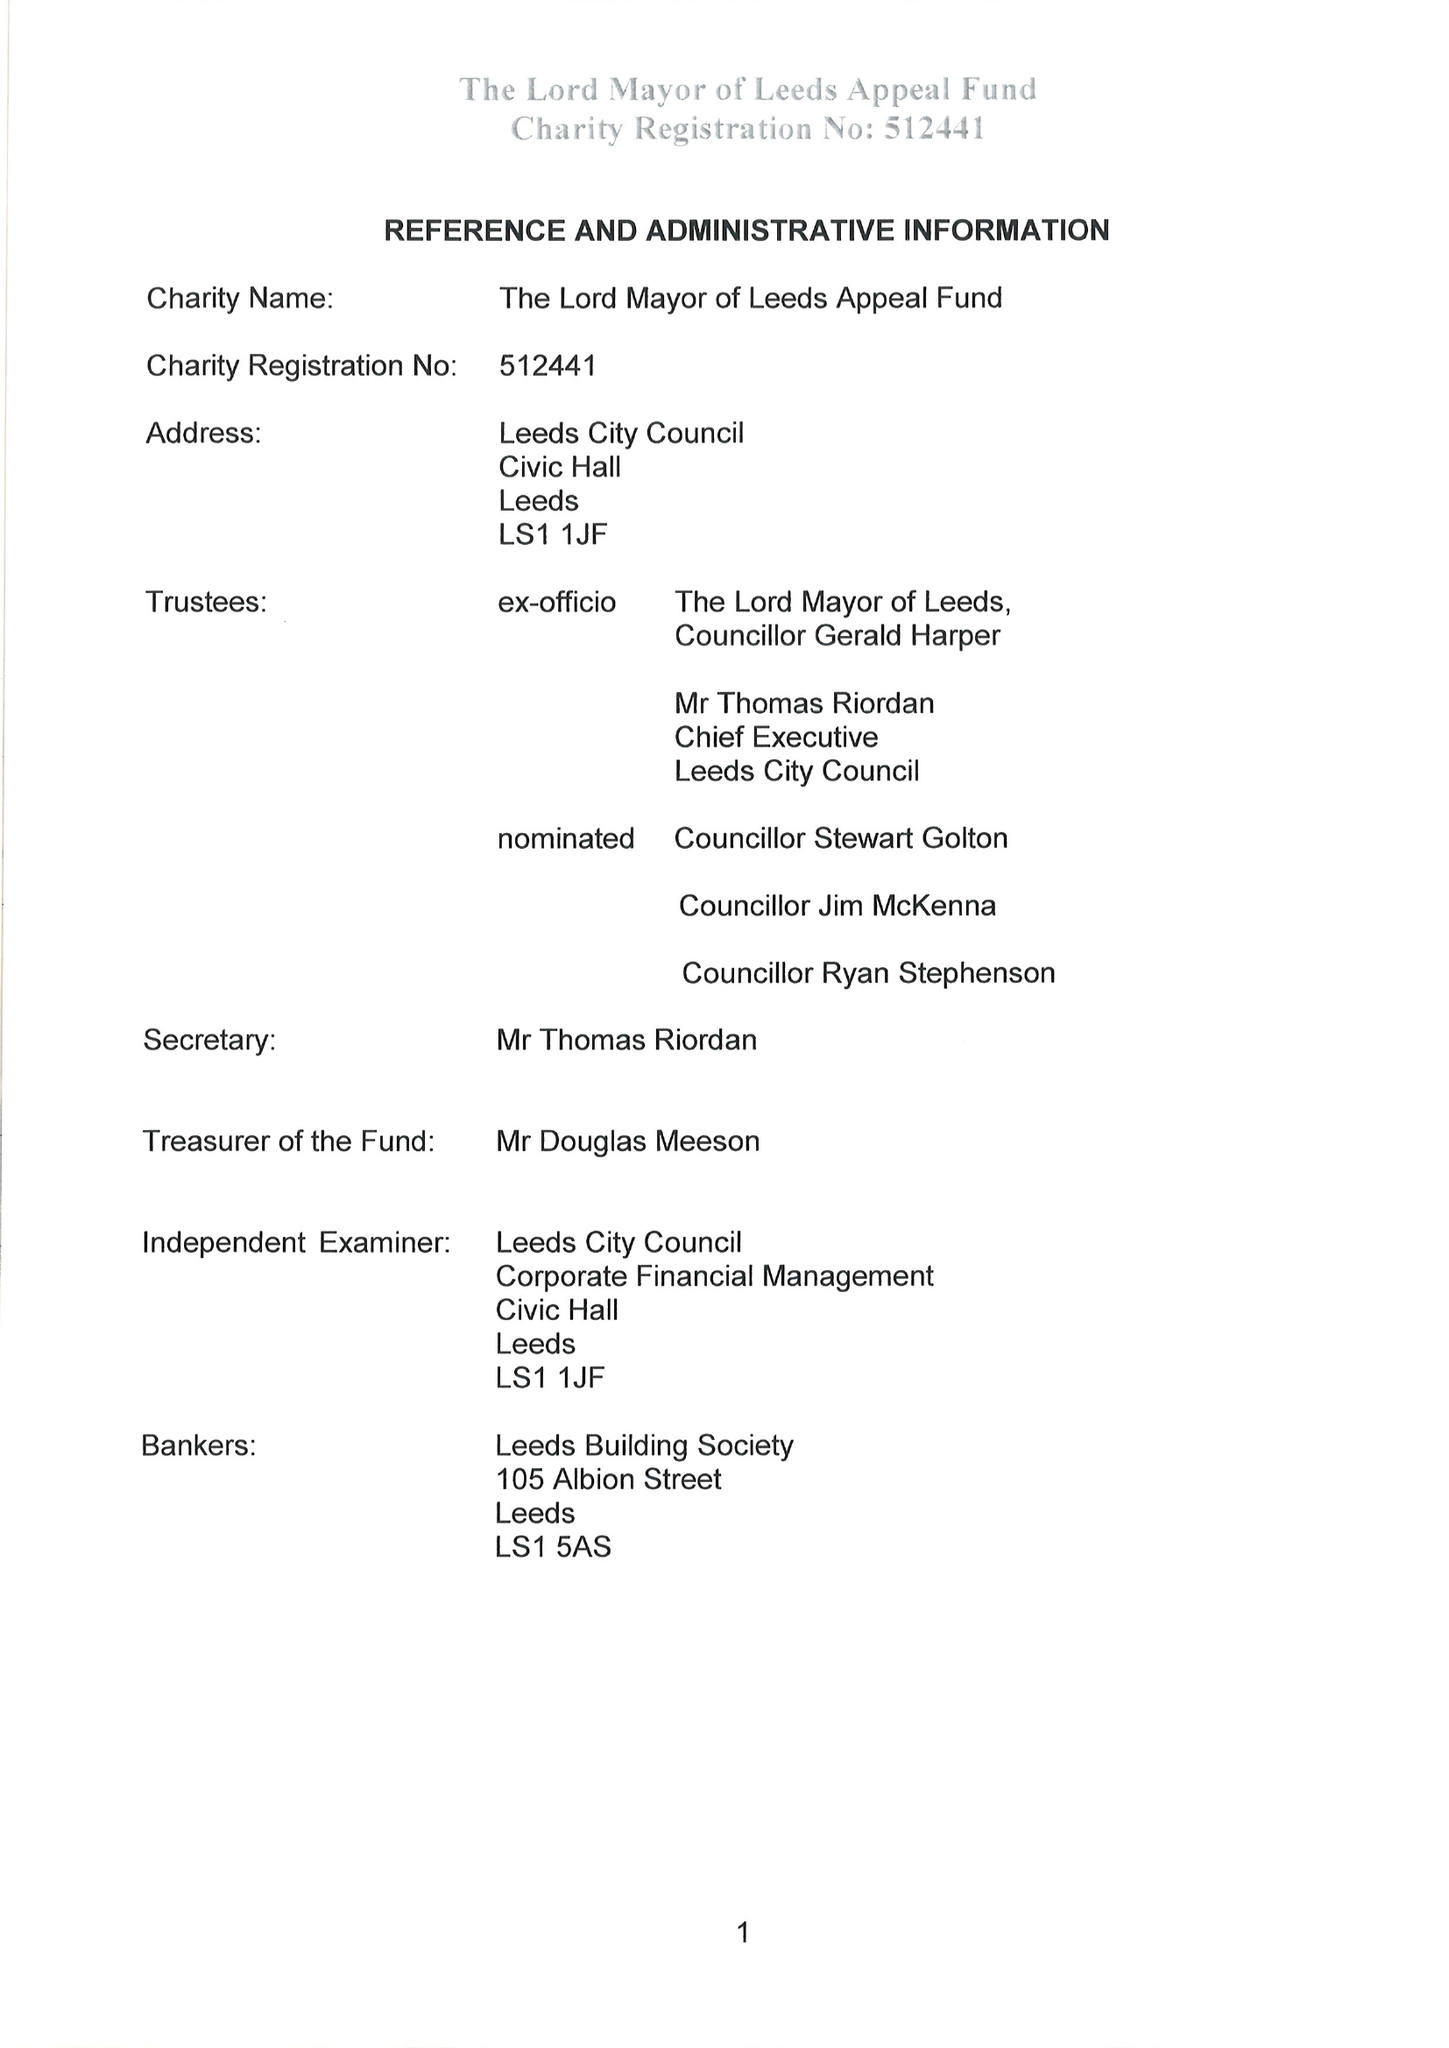What is the value for the address__street_line?
Answer the question using a single word or phrase. None 